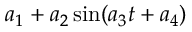Convert formula to latex. <formula><loc_0><loc_0><loc_500><loc_500>a _ { 1 } + a _ { 2 } \sin ( a _ { 3 } t + a _ { 4 } )</formula> 